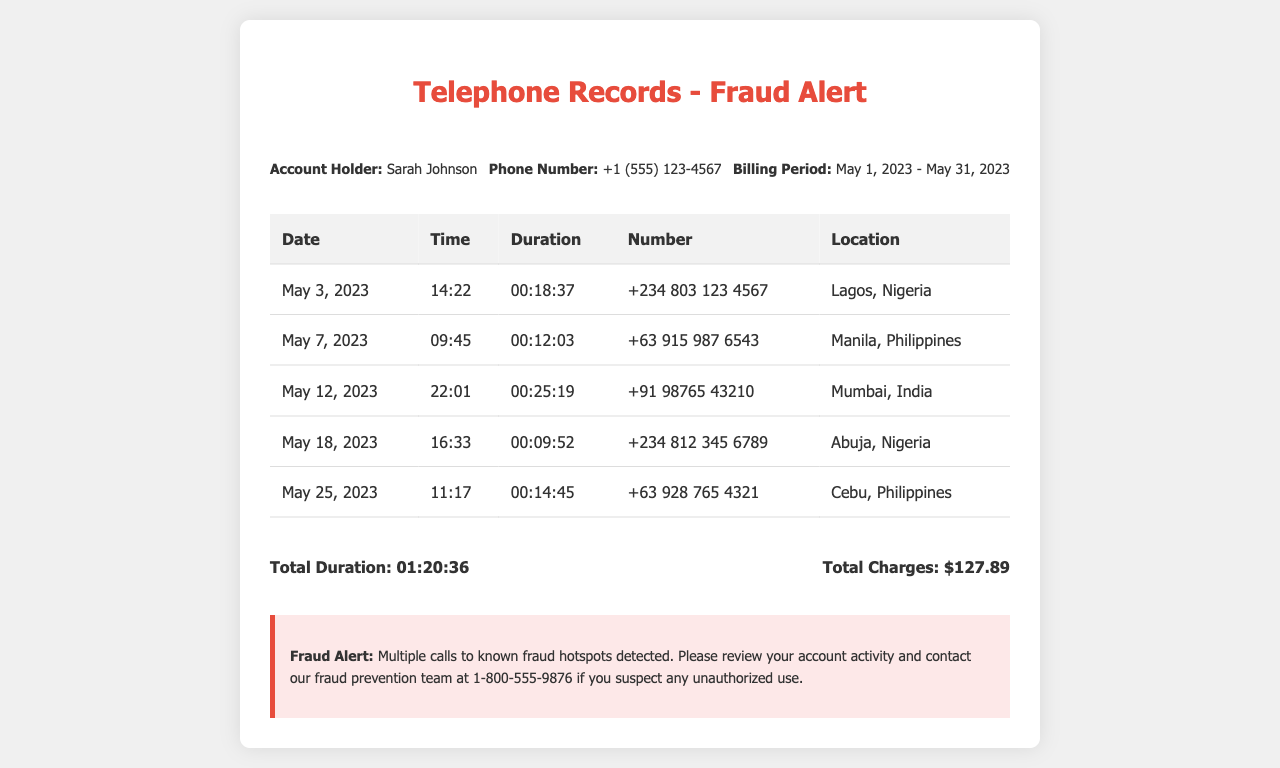What is the name of the account holder? The account holder's name is shown in the document as "Sarah Johnson".
Answer: Sarah Johnson What is the phone number listed in the document? The phone number is provided in the contact details section, which is "+1 (555) 123-4567".
Answer: +1 (555) 123-4567 How many calls were made to Nigeria? The document lists two calls made to Nigeria under the "Location" column.
Answer: 2 What was the total duration of all calls? The total duration is calculated in the document and summarized at the end, which is "01:20:36".
Answer: 01:20:36 What is the total charge for the calls? The total charges for the calls are explicitly mentioned and summed up in the document, which is "$127.89".
Answer: $127.89 Which city in the Philippines was called on May 25, 2023? The document lists the city “Cebu” under the date May 25, 2023.
Answer: Cebu What time was the call made to Mumbai, India? The call to Mumbai is logged at "22:01" on May 12, 2023.
Answer: 22:01 Is there a fraud alert mentioned in the document? A fraud alert is included in the document that warns about suspicious calls.
Answer: Yes What was the date of the first call? The first call in the log is dated May 3, 2023, based on the entries provided in the table.
Answer: May 3, 2023 